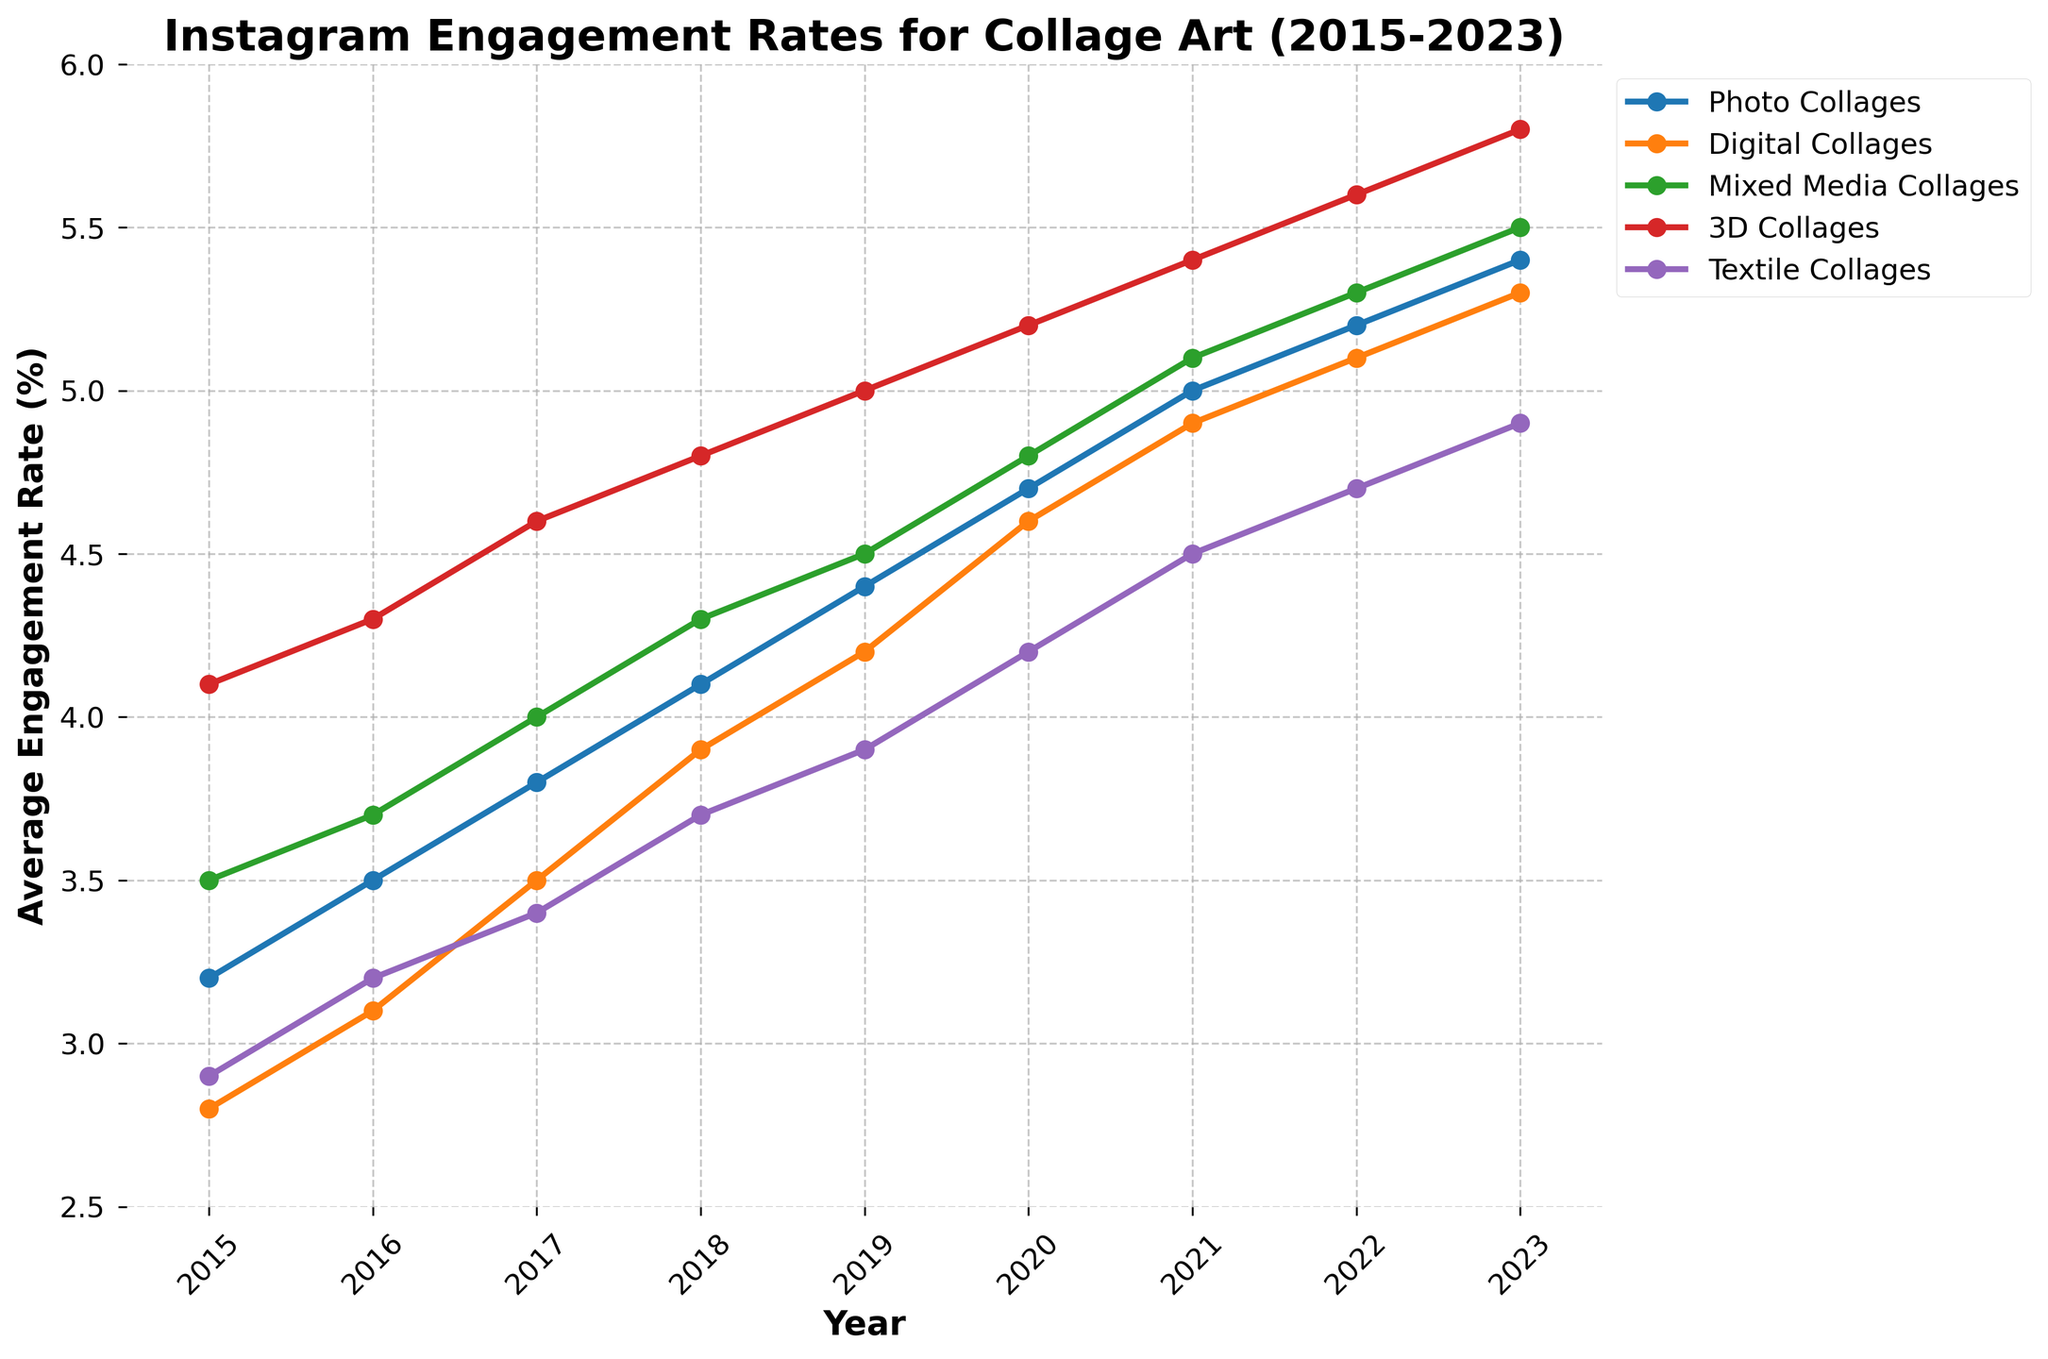which type of collage art post had the highest engagement rate in 2023? The 2023 data shows that the 3D Collages category had the highest engagement rate, as its line is the highest on the chart.
Answer: 3D Collages how did the engagement rate for Photo Collages change from 2015 to 2023? In 2015, the engagement rate for Photo Collages was 3.2%, and it increased to 5.4% in 2023, showing a consistent upward trend each year.
Answer: Increased which type of collage art consistently had the lowest engagement rate? By observing the trend lines, Textile Collages consistently had the lowest engagement rate each year from 2015 to 2023.
Answer: Textile Collages what was the average engagement rate for Digital Collages over the period 2015 to 2023? Adding the yearly engagement rates for Digital Collages (2.8%, 3.1%, 3.5%, 3.9%, 4.2%, 4.6%, 4.9%, 5.1%, 5.3%) and dividing by the number of years (9): (2.8+3.1+3.5+3.9+4.2+4.6+4.9+5.1+5.3)/9.
Answer: 4.15% which year saw the largest increase in engagement rate for Mixed Media Collages? The largest increase in engagement rate for Mixed Media Collages occurred between 2017 and 2018, where it increased from 4.0% to 4.3%.
Answer: 2018 were engagement rates for Textile Collages ever higher than Digital Collages? By observing the trend lines, we can see that the engagement rate for Textile Collages was never higher than that for Digital Collages from 2015 to 2023.
Answer: No which collage art type had the most consistent increase in engagement rate year over year? By observing the smoothness and steadiness of the upward trend lines, Photo Collages had the most consistent increase in engagement rate from 2015 to 2023.
Answer: Photo Collages how much more was the engagement rate for 3D Collages than Textile Collages in 2023? In 2023, the engagement rate for 3D Collages was 5.8%, and for Textile Collages, it was 4.9%. The difference is 5.8% - 4.9%.
Answer: 0.9% what is the trend for the engagement rate of Mixed Media Collages over the years? The engagement rate for Mixed Media Collages shows a general upward trend from 3.5% in 2015 to 5.5% in 2023.
Answer: Upward trend compare the engagement rate of Photo Collages and Digital Collages in 2019? In 2019, the engagement rate for Photo Collages was 4.4% and for Digital Collages, it was 4.2%. Photo Collages had a higher rate.
Answer: Photo Collages 